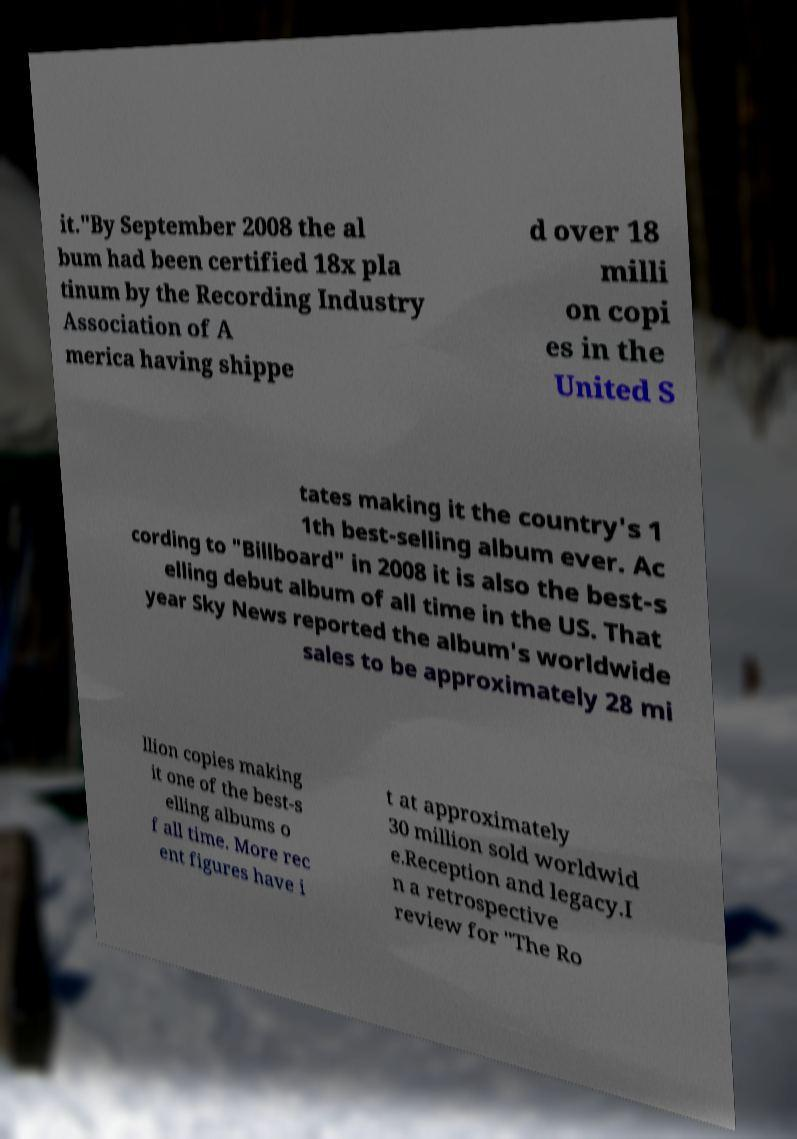Can you accurately transcribe the text from the provided image for me? it."By September 2008 the al bum had been certified 18x pla tinum by the Recording Industry Association of A merica having shippe d over 18 milli on copi es in the United S tates making it the country's 1 1th best-selling album ever. Ac cording to "Billboard" in 2008 it is also the best-s elling debut album of all time in the US. That year Sky News reported the album's worldwide sales to be approximately 28 mi llion copies making it one of the best-s elling albums o f all time. More rec ent figures have i t at approximately 30 million sold worldwid e.Reception and legacy.I n a retrospective review for "The Ro 